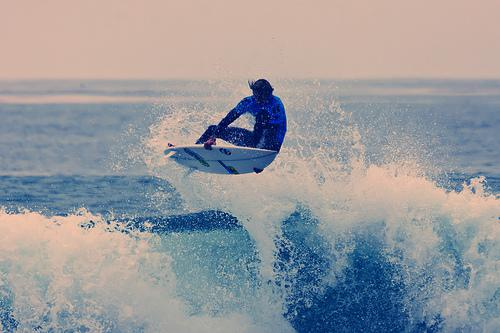Question: why is the surfer in the air?
Choices:
A. Flew off his board.
B. Jumped a wave.
C. Hit by the boat.
D. Doing a trick.
Answer with the letter. Answer: B 